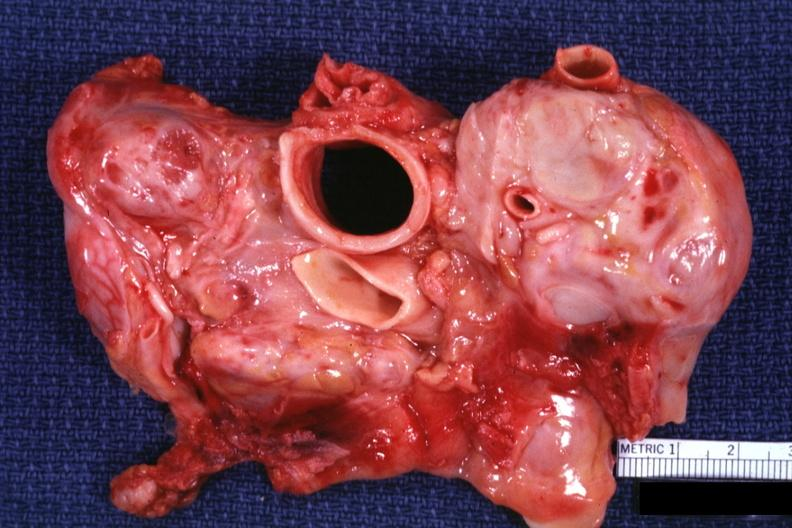s metastatic carcinoma present?
Answer the question using a single word or phrase. Yes 